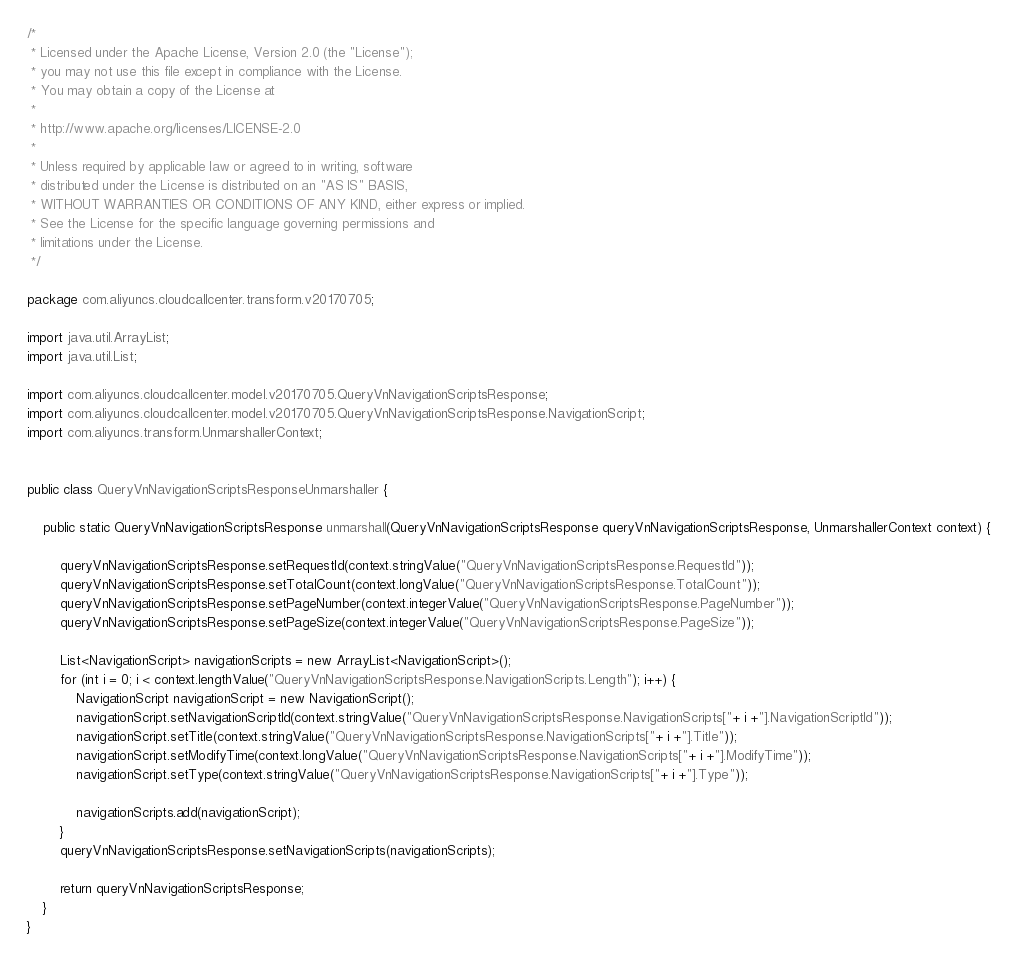Convert code to text. <code><loc_0><loc_0><loc_500><loc_500><_Java_>/*
 * Licensed under the Apache License, Version 2.0 (the "License");
 * you may not use this file except in compliance with the License.
 * You may obtain a copy of the License at
 *
 * http://www.apache.org/licenses/LICENSE-2.0
 *
 * Unless required by applicable law or agreed to in writing, software
 * distributed under the License is distributed on an "AS IS" BASIS,
 * WITHOUT WARRANTIES OR CONDITIONS OF ANY KIND, either express or implied.
 * See the License for the specific language governing permissions and
 * limitations under the License.
 */

package com.aliyuncs.cloudcallcenter.transform.v20170705;

import java.util.ArrayList;
import java.util.List;

import com.aliyuncs.cloudcallcenter.model.v20170705.QueryVnNavigationScriptsResponse;
import com.aliyuncs.cloudcallcenter.model.v20170705.QueryVnNavigationScriptsResponse.NavigationScript;
import com.aliyuncs.transform.UnmarshallerContext;


public class QueryVnNavigationScriptsResponseUnmarshaller {

	public static QueryVnNavigationScriptsResponse unmarshall(QueryVnNavigationScriptsResponse queryVnNavigationScriptsResponse, UnmarshallerContext context) {
		
		queryVnNavigationScriptsResponse.setRequestId(context.stringValue("QueryVnNavigationScriptsResponse.RequestId"));
		queryVnNavigationScriptsResponse.setTotalCount(context.longValue("QueryVnNavigationScriptsResponse.TotalCount"));
		queryVnNavigationScriptsResponse.setPageNumber(context.integerValue("QueryVnNavigationScriptsResponse.PageNumber"));
		queryVnNavigationScriptsResponse.setPageSize(context.integerValue("QueryVnNavigationScriptsResponse.PageSize"));

		List<NavigationScript> navigationScripts = new ArrayList<NavigationScript>();
		for (int i = 0; i < context.lengthValue("QueryVnNavigationScriptsResponse.NavigationScripts.Length"); i++) {
			NavigationScript navigationScript = new NavigationScript();
			navigationScript.setNavigationScriptId(context.stringValue("QueryVnNavigationScriptsResponse.NavigationScripts["+ i +"].NavigationScriptId"));
			navigationScript.setTitle(context.stringValue("QueryVnNavigationScriptsResponse.NavigationScripts["+ i +"].Title"));
			navigationScript.setModifyTime(context.longValue("QueryVnNavigationScriptsResponse.NavigationScripts["+ i +"].ModifyTime"));
			navigationScript.setType(context.stringValue("QueryVnNavigationScriptsResponse.NavigationScripts["+ i +"].Type"));

			navigationScripts.add(navigationScript);
		}
		queryVnNavigationScriptsResponse.setNavigationScripts(navigationScripts);
	 
	 	return queryVnNavigationScriptsResponse;
	}
}</code> 